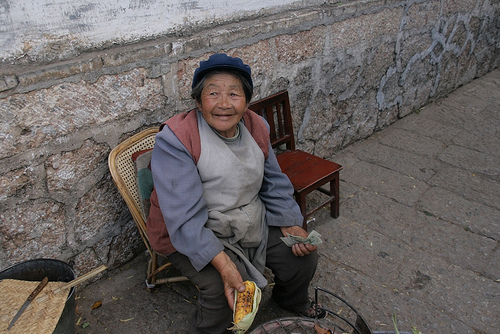<image>
Can you confirm if the woman is on the chair? Yes. Looking at the image, I can see the woman is positioned on top of the chair, with the chair providing support. 